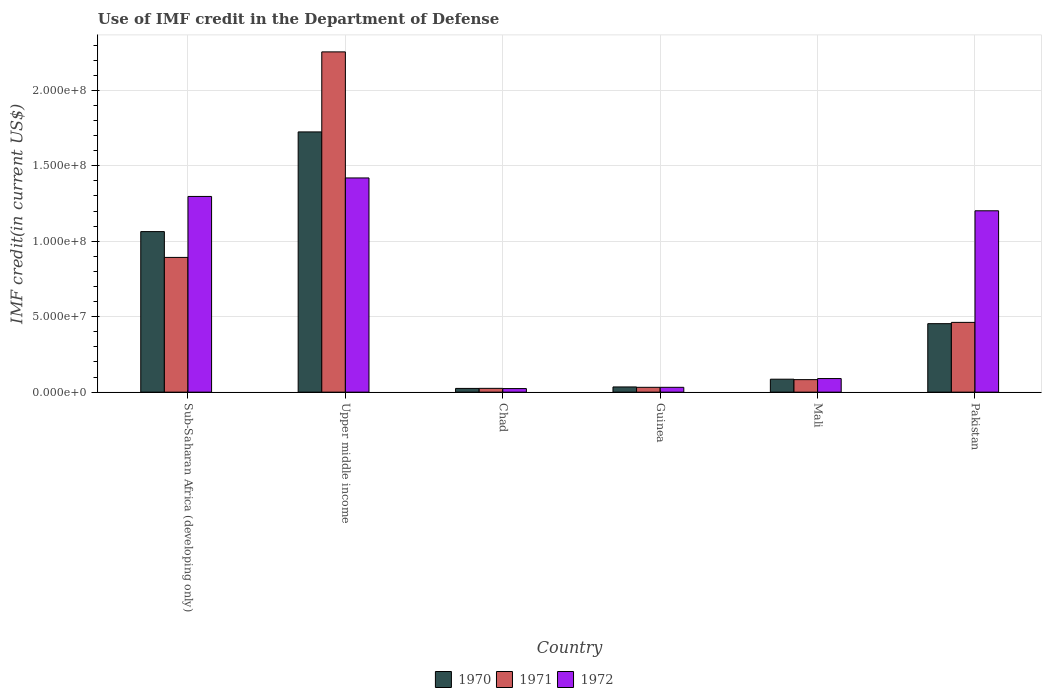How many groups of bars are there?
Offer a very short reply. 6. How many bars are there on the 5th tick from the right?
Your answer should be compact. 3. What is the label of the 2nd group of bars from the left?
Your answer should be compact. Upper middle income. In how many cases, is the number of bars for a given country not equal to the number of legend labels?
Provide a succinct answer. 0. What is the IMF credit in the Department of Defense in 1972 in Upper middle income?
Keep it short and to the point. 1.42e+08. Across all countries, what is the maximum IMF credit in the Department of Defense in 1970?
Provide a short and direct response. 1.72e+08. Across all countries, what is the minimum IMF credit in the Department of Defense in 1972?
Give a very brief answer. 2.37e+06. In which country was the IMF credit in the Department of Defense in 1972 maximum?
Offer a terse response. Upper middle income. In which country was the IMF credit in the Department of Defense in 1971 minimum?
Keep it short and to the point. Chad. What is the total IMF credit in the Department of Defense in 1971 in the graph?
Offer a very short reply. 3.75e+08. What is the difference between the IMF credit in the Department of Defense in 1971 in Chad and that in Sub-Saharan Africa (developing only)?
Offer a very short reply. -8.68e+07. What is the difference between the IMF credit in the Department of Defense in 1970 in Guinea and the IMF credit in the Department of Defense in 1972 in Chad?
Your answer should be very brief. 1.08e+06. What is the average IMF credit in the Department of Defense in 1971 per country?
Keep it short and to the point. 6.25e+07. What is the difference between the IMF credit in the Department of Defense of/in 1972 and IMF credit in the Department of Defense of/in 1970 in Chad?
Keep it short and to the point. -1.03e+05. In how many countries, is the IMF credit in the Department of Defense in 1970 greater than 220000000 US$?
Offer a very short reply. 0. What is the ratio of the IMF credit in the Department of Defense in 1971 in Guinea to that in Pakistan?
Provide a succinct answer. 0.07. What is the difference between the highest and the second highest IMF credit in the Department of Defense in 1972?
Provide a short and direct response. 2.18e+07. What is the difference between the highest and the lowest IMF credit in the Department of Defense in 1972?
Provide a short and direct response. 1.40e+08. In how many countries, is the IMF credit in the Department of Defense in 1972 greater than the average IMF credit in the Department of Defense in 1972 taken over all countries?
Your answer should be compact. 3. Is the sum of the IMF credit in the Department of Defense in 1972 in Pakistan and Sub-Saharan Africa (developing only) greater than the maximum IMF credit in the Department of Defense in 1970 across all countries?
Make the answer very short. Yes. What does the 1st bar from the left in Sub-Saharan Africa (developing only) represents?
Your answer should be compact. 1970. How many bars are there?
Provide a succinct answer. 18. Are all the bars in the graph horizontal?
Provide a short and direct response. No. How many countries are there in the graph?
Your answer should be very brief. 6. What is the title of the graph?
Make the answer very short. Use of IMF credit in the Department of Defense. Does "1992" appear as one of the legend labels in the graph?
Provide a succinct answer. No. What is the label or title of the X-axis?
Your answer should be compact. Country. What is the label or title of the Y-axis?
Your response must be concise. IMF credit(in current US$). What is the IMF credit(in current US$) in 1970 in Sub-Saharan Africa (developing only)?
Your response must be concise. 1.06e+08. What is the IMF credit(in current US$) in 1971 in Sub-Saharan Africa (developing only)?
Offer a terse response. 8.93e+07. What is the IMF credit(in current US$) in 1972 in Sub-Saharan Africa (developing only)?
Your answer should be compact. 1.30e+08. What is the IMF credit(in current US$) in 1970 in Upper middle income?
Your response must be concise. 1.72e+08. What is the IMF credit(in current US$) of 1971 in Upper middle income?
Make the answer very short. 2.25e+08. What is the IMF credit(in current US$) of 1972 in Upper middle income?
Provide a succinct answer. 1.42e+08. What is the IMF credit(in current US$) in 1970 in Chad?
Ensure brevity in your answer.  2.47e+06. What is the IMF credit(in current US$) of 1971 in Chad?
Provide a short and direct response. 2.52e+06. What is the IMF credit(in current US$) of 1972 in Chad?
Offer a terse response. 2.37e+06. What is the IMF credit(in current US$) of 1970 in Guinea?
Provide a short and direct response. 3.45e+06. What is the IMF credit(in current US$) of 1971 in Guinea?
Give a very brief answer. 3.20e+06. What is the IMF credit(in current US$) of 1972 in Guinea?
Offer a very short reply. 3.20e+06. What is the IMF credit(in current US$) in 1970 in Mali?
Keep it short and to the point. 8.58e+06. What is the IMF credit(in current US$) of 1971 in Mali?
Your response must be concise. 8.30e+06. What is the IMF credit(in current US$) in 1972 in Mali?
Your response must be concise. 9.01e+06. What is the IMF credit(in current US$) in 1970 in Pakistan?
Your answer should be compact. 4.54e+07. What is the IMF credit(in current US$) of 1971 in Pakistan?
Offer a very short reply. 4.62e+07. What is the IMF credit(in current US$) in 1972 in Pakistan?
Provide a succinct answer. 1.20e+08. Across all countries, what is the maximum IMF credit(in current US$) of 1970?
Your answer should be compact. 1.72e+08. Across all countries, what is the maximum IMF credit(in current US$) in 1971?
Make the answer very short. 2.25e+08. Across all countries, what is the maximum IMF credit(in current US$) of 1972?
Ensure brevity in your answer.  1.42e+08. Across all countries, what is the minimum IMF credit(in current US$) of 1970?
Your answer should be compact. 2.47e+06. Across all countries, what is the minimum IMF credit(in current US$) of 1971?
Your response must be concise. 2.52e+06. Across all countries, what is the minimum IMF credit(in current US$) in 1972?
Your answer should be compact. 2.37e+06. What is the total IMF credit(in current US$) in 1970 in the graph?
Your response must be concise. 3.39e+08. What is the total IMF credit(in current US$) of 1971 in the graph?
Provide a succinct answer. 3.75e+08. What is the total IMF credit(in current US$) in 1972 in the graph?
Provide a short and direct response. 4.06e+08. What is the difference between the IMF credit(in current US$) of 1970 in Sub-Saharan Africa (developing only) and that in Upper middle income?
Ensure brevity in your answer.  -6.61e+07. What is the difference between the IMF credit(in current US$) in 1971 in Sub-Saharan Africa (developing only) and that in Upper middle income?
Your answer should be very brief. -1.36e+08. What is the difference between the IMF credit(in current US$) of 1972 in Sub-Saharan Africa (developing only) and that in Upper middle income?
Ensure brevity in your answer.  -1.23e+07. What is the difference between the IMF credit(in current US$) of 1970 in Sub-Saharan Africa (developing only) and that in Chad?
Offer a terse response. 1.04e+08. What is the difference between the IMF credit(in current US$) in 1971 in Sub-Saharan Africa (developing only) and that in Chad?
Give a very brief answer. 8.68e+07. What is the difference between the IMF credit(in current US$) in 1972 in Sub-Saharan Africa (developing only) and that in Chad?
Your answer should be very brief. 1.27e+08. What is the difference between the IMF credit(in current US$) of 1970 in Sub-Saharan Africa (developing only) and that in Guinea?
Make the answer very short. 1.03e+08. What is the difference between the IMF credit(in current US$) of 1971 in Sub-Saharan Africa (developing only) and that in Guinea?
Offer a very short reply. 8.61e+07. What is the difference between the IMF credit(in current US$) in 1972 in Sub-Saharan Africa (developing only) and that in Guinea?
Provide a short and direct response. 1.26e+08. What is the difference between the IMF credit(in current US$) of 1970 in Sub-Saharan Africa (developing only) and that in Mali?
Make the answer very short. 9.78e+07. What is the difference between the IMF credit(in current US$) of 1971 in Sub-Saharan Africa (developing only) and that in Mali?
Your response must be concise. 8.10e+07. What is the difference between the IMF credit(in current US$) of 1972 in Sub-Saharan Africa (developing only) and that in Mali?
Offer a terse response. 1.21e+08. What is the difference between the IMF credit(in current US$) in 1970 in Sub-Saharan Africa (developing only) and that in Pakistan?
Make the answer very short. 6.10e+07. What is the difference between the IMF credit(in current US$) of 1971 in Sub-Saharan Africa (developing only) and that in Pakistan?
Ensure brevity in your answer.  4.31e+07. What is the difference between the IMF credit(in current US$) in 1972 in Sub-Saharan Africa (developing only) and that in Pakistan?
Your response must be concise. 9.50e+06. What is the difference between the IMF credit(in current US$) of 1970 in Upper middle income and that in Chad?
Keep it short and to the point. 1.70e+08. What is the difference between the IMF credit(in current US$) in 1971 in Upper middle income and that in Chad?
Keep it short and to the point. 2.23e+08. What is the difference between the IMF credit(in current US$) in 1972 in Upper middle income and that in Chad?
Give a very brief answer. 1.40e+08. What is the difference between the IMF credit(in current US$) in 1970 in Upper middle income and that in Guinea?
Your answer should be compact. 1.69e+08. What is the difference between the IMF credit(in current US$) in 1971 in Upper middle income and that in Guinea?
Offer a terse response. 2.22e+08. What is the difference between the IMF credit(in current US$) of 1972 in Upper middle income and that in Guinea?
Give a very brief answer. 1.39e+08. What is the difference between the IMF credit(in current US$) in 1970 in Upper middle income and that in Mali?
Your answer should be very brief. 1.64e+08. What is the difference between the IMF credit(in current US$) in 1971 in Upper middle income and that in Mali?
Provide a succinct answer. 2.17e+08. What is the difference between the IMF credit(in current US$) in 1972 in Upper middle income and that in Mali?
Offer a very short reply. 1.33e+08. What is the difference between the IMF credit(in current US$) of 1970 in Upper middle income and that in Pakistan?
Provide a succinct answer. 1.27e+08. What is the difference between the IMF credit(in current US$) of 1971 in Upper middle income and that in Pakistan?
Offer a very short reply. 1.79e+08. What is the difference between the IMF credit(in current US$) in 1972 in Upper middle income and that in Pakistan?
Ensure brevity in your answer.  2.18e+07. What is the difference between the IMF credit(in current US$) in 1970 in Chad and that in Guinea?
Offer a terse response. -9.80e+05. What is the difference between the IMF credit(in current US$) of 1971 in Chad and that in Guinea?
Ensure brevity in your answer.  -6.84e+05. What is the difference between the IMF credit(in current US$) of 1972 in Chad and that in Guinea?
Provide a short and direct response. -8.36e+05. What is the difference between the IMF credit(in current US$) of 1970 in Chad and that in Mali?
Your response must be concise. -6.11e+06. What is the difference between the IMF credit(in current US$) of 1971 in Chad and that in Mali?
Your answer should be compact. -5.78e+06. What is the difference between the IMF credit(in current US$) in 1972 in Chad and that in Mali?
Offer a terse response. -6.64e+06. What is the difference between the IMF credit(in current US$) in 1970 in Chad and that in Pakistan?
Keep it short and to the point. -4.29e+07. What is the difference between the IMF credit(in current US$) of 1971 in Chad and that in Pakistan?
Provide a short and direct response. -4.37e+07. What is the difference between the IMF credit(in current US$) of 1972 in Chad and that in Pakistan?
Give a very brief answer. -1.18e+08. What is the difference between the IMF credit(in current US$) in 1970 in Guinea and that in Mali?
Give a very brief answer. -5.13e+06. What is the difference between the IMF credit(in current US$) of 1971 in Guinea and that in Mali?
Ensure brevity in your answer.  -5.09e+06. What is the difference between the IMF credit(in current US$) in 1972 in Guinea and that in Mali?
Keep it short and to the point. -5.81e+06. What is the difference between the IMF credit(in current US$) of 1970 in Guinea and that in Pakistan?
Your answer should be compact. -4.19e+07. What is the difference between the IMF credit(in current US$) of 1971 in Guinea and that in Pakistan?
Offer a very short reply. -4.30e+07. What is the difference between the IMF credit(in current US$) in 1972 in Guinea and that in Pakistan?
Provide a short and direct response. -1.17e+08. What is the difference between the IMF credit(in current US$) of 1970 in Mali and that in Pakistan?
Offer a terse response. -3.68e+07. What is the difference between the IMF credit(in current US$) in 1971 in Mali and that in Pakistan?
Your response must be concise. -3.79e+07. What is the difference between the IMF credit(in current US$) of 1972 in Mali and that in Pakistan?
Your response must be concise. -1.11e+08. What is the difference between the IMF credit(in current US$) of 1970 in Sub-Saharan Africa (developing only) and the IMF credit(in current US$) of 1971 in Upper middle income?
Your answer should be compact. -1.19e+08. What is the difference between the IMF credit(in current US$) in 1970 in Sub-Saharan Africa (developing only) and the IMF credit(in current US$) in 1972 in Upper middle income?
Ensure brevity in your answer.  -3.56e+07. What is the difference between the IMF credit(in current US$) of 1971 in Sub-Saharan Africa (developing only) and the IMF credit(in current US$) of 1972 in Upper middle income?
Keep it short and to the point. -5.27e+07. What is the difference between the IMF credit(in current US$) in 1970 in Sub-Saharan Africa (developing only) and the IMF credit(in current US$) in 1971 in Chad?
Ensure brevity in your answer.  1.04e+08. What is the difference between the IMF credit(in current US$) of 1970 in Sub-Saharan Africa (developing only) and the IMF credit(in current US$) of 1972 in Chad?
Make the answer very short. 1.04e+08. What is the difference between the IMF credit(in current US$) of 1971 in Sub-Saharan Africa (developing only) and the IMF credit(in current US$) of 1972 in Chad?
Offer a terse response. 8.69e+07. What is the difference between the IMF credit(in current US$) of 1970 in Sub-Saharan Africa (developing only) and the IMF credit(in current US$) of 1971 in Guinea?
Your response must be concise. 1.03e+08. What is the difference between the IMF credit(in current US$) of 1970 in Sub-Saharan Africa (developing only) and the IMF credit(in current US$) of 1972 in Guinea?
Provide a short and direct response. 1.03e+08. What is the difference between the IMF credit(in current US$) in 1971 in Sub-Saharan Africa (developing only) and the IMF credit(in current US$) in 1972 in Guinea?
Provide a succinct answer. 8.61e+07. What is the difference between the IMF credit(in current US$) of 1970 in Sub-Saharan Africa (developing only) and the IMF credit(in current US$) of 1971 in Mali?
Make the answer very short. 9.81e+07. What is the difference between the IMF credit(in current US$) of 1970 in Sub-Saharan Africa (developing only) and the IMF credit(in current US$) of 1972 in Mali?
Offer a very short reply. 9.74e+07. What is the difference between the IMF credit(in current US$) in 1971 in Sub-Saharan Africa (developing only) and the IMF credit(in current US$) in 1972 in Mali?
Give a very brief answer. 8.03e+07. What is the difference between the IMF credit(in current US$) in 1970 in Sub-Saharan Africa (developing only) and the IMF credit(in current US$) in 1971 in Pakistan?
Give a very brief answer. 6.02e+07. What is the difference between the IMF credit(in current US$) of 1970 in Sub-Saharan Africa (developing only) and the IMF credit(in current US$) of 1972 in Pakistan?
Provide a short and direct response. -1.38e+07. What is the difference between the IMF credit(in current US$) of 1971 in Sub-Saharan Africa (developing only) and the IMF credit(in current US$) of 1972 in Pakistan?
Your answer should be compact. -3.09e+07. What is the difference between the IMF credit(in current US$) of 1970 in Upper middle income and the IMF credit(in current US$) of 1971 in Chad?
Provide a succinct answer. 1.70e+08. What is the difference between the IMF credit(in current US$) of 1970 in Upper middle income and the IMF credit(in current US$) of 1972 in Chad?
Provide a short and direct response. 1.70e+08. What is the difference between the IMF credit(in current US$) in 1971 in Upper middle income and the IMF credit(in current US$) in 1972 in Chad?
Make the answer very short. 2.23e+08. What is the difference between the IMF credit(in current US$) in 1970 in Upper middle income and the IMF credit(in current US$) in 1971 in Guinea?
Your answer should be compact. 1.69e+08. What is the difference between the IMF credit(in current US$) in 1970 in Upper middle income and the IMF credit(in current US$) in 1972 in Guinea?
Offer a very short reply. 1.69e+08. What is the difference between the IMF credit(in current US$) of 1971 in Upper middle income and the IMF credit(in current US$) of 1972 in Guinea?
Provide a succinct answer. 2.22e+08. What is the difference between the IMF credit(in current US$) in 1970 in Upper middle income and the IMF credit(in current US$) in 1971 in Mali?
Your answer should be compact. 1.64e+08. What is the difference between the IMF credit(in current US$) of 1970 in Upper middle income and the IMF credit(in current US$) of 1972 in Mali?
Your answer should be very brief. 1.63e+08. What is the difference between the IMF credit(in current US$) of 1971 in Upper middle income and the IMF credit(in current US$) of 1972 in Mali?
Provide a short and direct response. 2.16e+08. What is the difference between the IMF credit(in current US$) in 1970 in Upper middle income and the IMF credit(in current US$) in 1971 in Pakistan?
Make the answer very short. 1.26e+08. What is the difference between the IMF credit(in current US$) in 1970 in Upper middle income and the IMF credit(in current US$) in 1972 in Pakistan?
Give a very brief answer. 5.23e+07. What is the difference between the IMF credit(in current US$) of 1971 in Upper middle income and the IMF credit(in current US$) of 1972 in Pakistan?
Offer a terse response. 1.05e+08. What is the difference between the IMF credit(in current US$) of 1970 in Chad and the IMF credit(in current US$) of 1971 in Guinea?
Your answer should be very brief. -7.33e+05. What is the difference between the IMF credit(in current US$) of 1970 in Chad and the IMF credit(in current US$) of 1972 in Guinea?
Provide a short and direct response. -7.33e+05. What is the difference between the IMF credit(in current US$) of 1971 in Chad and the IMF credit(in current US$) of 1972 in Guinea?
Keep it short and to the point. -6.84e+05. What is the difference between the IMF credit(in current US$) in 1970 in Chad and the IMF credit(in current US$) in 1971 in Mali?
Ensure brevity in your answer.  -5.82e+06. What is the difference between the IMF credit(in current US$) in 1970 in Chad and the IMF credit(in current US$) in 1972 in Mali?
Offer a very short reply. -6.54e+06. What is the difference between the IMF credit(in current US$) in 1971 in Chad and the IMF credit(in current US$) in 1972 in Mali?
Offer a very short reply. -6.49e+06. What is the difference between the IMF credit(in current US$) in 1970 in Chad and the IMF credit(in current US$) in 1971 in Pakistan?
Your answer should be very brief. -4.38e+07. What is the difference between the IMF credit(in current US$) of 1970 in Chad and the IMF credit(in current US$) of 1972 in Pakistan?
Offer a terse response. -1.18e+08. What is the difference between the IMF credit(in current US$) of 1971 in Chad and the IMF credit(in current US$) of 1972 in Pakistan?
Offer a very short reply. -1.18e+08. What is the difference between the IMF credit(in current US$) of 1970 in Guinea and the IMF credit(in current US$) of 1971 in Mali?
Your response must be concise. -4.84e+06. What is the difference between the IMF credit(in current US$) of 1970 in Guinea and the IMF credit(in current US$) of 1972 in Mali?
Provide a short and direct response. -5.56e+06. What is the difference between the IMF credit(in current US$) in 1971 in Guinea and the IMF credit(in current US$) in 1972 in Mali?
Provide a short and direct response. -5.81e+06. What is the difference between the IMF credit(in current US$) of 1970 in Guinea and the IMF credit(in current US$) of 1971 in Pakistan?
Your answer should be very brief. -4.28e+07. What is the difference between the IMF credit(in current US$) in 1970 in Guinea and the IMF credit(in current US$) in 1972 in Pakistan?
Your answer should be very brief. -1.17e+08. What is the difference between the IMF credit(in current US$) in 1971 in Guinea and the IMF credit(in current US$) in 1972 in Pakistan?
Your response must be concise. -1.17e+08. What is the difference between the IMF credit(in current US$) of 1970 in Mali and the IMF credit(in current US$) of 1971 in Pakistan?
Keep it short and to the point. -3.77e+07. What is the difference between the IMF credit(in current US$) of 1970 in Mali and the IMF credit(in current US$) of 1972 in Pakistan?
Offer a terse response. -1.12e+08. What is the difference between the IMF credit(in current US$) of 1971 in Mali and the IMF credit(in current US$) of 1972 in Pakistan?
Offer a terse response. -1.12e+08. What is the average IMF credit(in current US$) in 1970 per country?
Keep it short and to the point. 5.65e+07. What is the average IMF credit(in current US$) in 1971 per country?
Your answer should be compact. 6.25e+07. What is the average IMF credit(in current US$) of 1972 per country?
Your response must be concise. 6.77e+07. What is the difference between the IMF credit(in current US$) in 1970 and IMF credit(in current US$) in 1971 in Sub-Saharan Africa (developing only)?
Your answer should be very brief. 1.71e+07. What is the difference between the IMF credit(in current US$) of 1970 and IMF credit(in current US$) of 1972 in Sub-Saharan Africa (developing only)?
Offer a very short reply. -2.33e+07. What is the difference between the IMF credit(in current US$) in 1971 and IMF credit(in current US$) in 1972 in Sub-Saharan Africa (developing only)?
Your answer should be compact. -4.04e+07. What is the difference between the IMF credit(in current US$) in 1970 and IMF credit(in current US$) in 1971 in Upper middle income?
Ensure brevity in your answer.  -5.30e+07. What is the difference between the IMF credit(in current US$) in 1970 and IMF credit(in current US$) in 1972 in Upper middle income?
Provide a short and direct response. 3.05e+07. What is the difference between the IMF credit(in current US$) of 1971 and IMF credit(in current US$) of 1972 in Upper middle income?
Your answer should be very brief. 8.35e+07. What is the difference between the IMF credit(in current US$) of 1970 and IMF credit(in current US$) of 1971 in Chad?
Give a very brief answer. -4.90e+04. What is the difference between the IMF credit(in current US$) of 1970 and IMF credit(in current US$) of 1972 in Chad?
Ensure brevity in your answer.  1.03e+05. What is the difference between the IMF credit(in current US$) of 1971 and IMF credit(in current US$) of 1972 in Chad?
Your answer should be very brief. 1.52e+05. What is the difference between the IMF credit(in current US$) in 1970 and IMF credit(in current US$) in 1971 in Guinea?
Provide a succinct answer. 2.47e+05. What is the difference between the IMF credit(in current US$) in 1970 and IMF credit(in current US$) in 1972 in Guinea?
Your response must be concise. 2.47e+05. What is the difference between the IMF credit(in current US$) in 1970 and IMF credit(in current US$) in 1971 in Mali?
Your response must be concise. 2.85e+05. What is the difference between the IMF credit(in current US$) of 1970 and IMF credit(in current US$) of 1972 in Mali?
Ensure brevity in your answer.  -4.31e+05. What is the difference between the IMF credit(in current US$) of 1971 and IMF credit(in current US$) of 1972 in Mali?
Make the answer very short. -7.16e+05. What is the difference between the IMF credit(in current US$) of 1970 and IMF credit(in current US$) of 1971 in Pakistan?
Give a very brief answer. -8.56e+05. What is the difference between the IMF credit(in current US$) in 1970 and IMF credit(in current US$) in 1972 in Pakistan?
Give a very brief answer. -7.48e+07. What is the difference between the IMF credit(in current US$) in 1971 and IMF credit(in current US$) in 1972 in Pakistan?
Provide a short and direct response. -7.40e+07. What is the ratio of the IMF credit(in current US$) in 1970 in Sub-Saharan Africa (developing only) to that in Upper middle income?
Provide a short and direct response. 0.62. What is the ratio of the IMF credit(in current US$) of 1971 in Sub-Saharan Africa (developing only) to that in Upper middle income?
Offer a very short reply. 0.4. What is the ratio of the IMF credit(in current US$) of 1972 in Sub-Saharan Africa (developing only) to that in Upper middle income?
Keep it short and to the point. 0.91. What is the ratio of the IMF credit(in current US$) in 1970 in Sub-Saharan Africa (developing only) to that in Chad?
Your answer should be compact. 43.07. What is the ratio of the IMF credit(in current US$) of 1971 in Sub-Saharan Africa (developing only) to that in Chad?
Offer a very short reply. 35.45. What is the ratio of the IMF credit(in current US$) in 1972 in Sub-Saharan Africa (developing only) to that in Chad?
Offer a very short reply. 54.79. What is the ratio of the IMF credit(in current US$) of 1970 in Sub-Saharan Africa (developing only) to that in Guinea?
Keep it short and to the point. 30.84. What is the ratio of the IMF credit(in current US$) in 1971 in Sub-Saharan Africa (developing only) to that in Guinea?
Give a very brief answer. 27.88. What is the ratio of the IMF credit(in current US$) of 1972 in Sub-Saharan Africa (developing only) to that in Guinea?
Provide a succinct answer. 40.49. What is the ratio of the IMF credit(in current US$) of 1970 in Sub-Saharan Africa (developing only) to that in Mali?
Your answer should be very brief. 12.4. What is the ratio of the IMF credit(in current US$) in 1971 in Sub-Saharan Africa (developing only) to that in Mali?
Offer a terse response. 10.76. What is the ratio of the IMF credit(in current US$) in 1972 in Sub-Saharan Africa (developing only) to that in Mali?
Offer a terse response. 14.39. What is the ratio of the IMF credit(in current US$) of 1970 in Sub-Saharan Africa (developing only) to that in Pakistan?
Provide a short and direct response. 2.34. What is the ratio of the IMF credit(in current US$) of 1971 in Sub-Saharan Africa (developing only) to that in Pakistan?
Provide a succinct answer. 1.93. What is the ratio of the IMF credit(in current US$) in 1972 in Sub-Saharan Africa (developing only) to that in Pakistan?
Your response must be concise. 1.08. What is the ratio of the IMF credit(in current US$) of 1970 in Upper middle income to that in Chad?
Your answer should be very brief. 69.82. What is the ratio of the IMF credit(in current US$) of 1971 in Upper middle income to that in Chad?
Give a very brief answer. 89.51. What is the ratio of the IMF credit(in current US$) in 1972 in Upper middle income to that in Chad?
Your answer should be compact. 59.97. What is the ratio of the IMF credit(in current US$) of 1970 in Upper middle income to that in Guinea?
Make the answer very short. 49.99. What is the ratio of the IMF credit(in current US$) of 1971 in Upper middle income to that in Guinea?
Ensure brevity in your answer.  70.4. What is the ratio of the IMF credit(in current US$) in 1972 in Upper middle income to that in Guinea?
Provide a short and direct response. 44.32. What is the ratio of the IMF credit(in current US$) in 1970 in Upper middle income to that in Mali?
Your answer should be very brief. 20.1. What is the ratio of the IMF credit(in current US$) in 1971 in Upper middle income to that in Mali?
Ensure brevity in your answer.  27.18. What is the ratio of the IMF credit(in current US$) of 1972 in Upper middle income to that in Mali?
Provide a succinct answer. 15.75. What is the ratio of the IMF credit(in current US$) in 1970 in Upper middle income to that in Pakistan?
Offer a terse response. 3.8. What is the ratio of the IMF credit(in current US$) in 1971 in Upper middle income to that in Pakistan?
Make the answer very short. 4.88. What is the ratio of the IMF credit(in current US$) in 1972 in Upper middle income to that in Pakistan?
Provide a succinct answer. 1.18. What is the ratio of the IMF credit(in current US$) of 1970 in Chad to that in Guinea?
Offer a terse response. 0.72. What is the ratio of the IMF credit(in current US$) in 1971 in Chad to that in Guinea?
Offer a terse response. 0.79. What is the ratio of the IMF credit(in current US$) of 1972 in Chad to that in Guinea?
Provide a succinct answer. 0.74. What is the ratio of the IMF credit(in current US$) in 1970 in Chad to that in Mali?
Offer a very short reply. 0.29. What is the ratio of the IMF credit(in current US$) of 1971 in Chad to that in Mali?
Your answer should be compact. 0.3. What is the ratio of the IMF credit(in current US$) in 1972 in Chad to that in Mali?
Your response must be concise. 0.26. What is the ratio of the IMF credit(in current US$) in 1970 in Chad to that in Pakistan?
Your answer should be very brief. 0.05. What is the ratio of the IMF credit(in current US$) in 1971 in Chad to that in Pakistan?
Ensure brevity in your answer.  0.05. What is the ratio of the IMF credit(in current US$) in 1972 in Chad to that in Pakistan?
Your answer should be compact. 0.02. What is the ratio of the IMF credit(in current US$) in 1970 in Guinea to that in Mali?
Provide a short and direct response. 0.4. What is the ratio of the IMF credit(in current US$) of 1971 in Guinea to that in Mali?
Offer a terse response. 0.39. What is the ratio of the IMF credit(in current US$) of 1972 in Guinea to that in Mali?
Your answer should be compact. 0.36. What is the ratio of the IMF credit(in current US$) in 1970 in Guinea to that in Pakistan?
Provide a succinct answer. 0.08. What is the ratio of the IMF credit(in current US$) of 1971 in Guinea to that in Pakistan?
Provide a short and direct response. 0.07. What is the ratio of the IMF credit(in current US$) of 1972 in Guinea to that in Pakistan?
Provide a short and direct response. 0.03. What is the ratio of the IMF credit(in current US$) of 1970 in Mali to that in Pakistan?
Give a very brief answer. 0.19. What is the ratio of the IMF credit(in current US$) in 1971 in Mali to that in Pakistan?
Provide a succinct answer. 0.18. What is the ratio of the IMF credit(in current US$) in 1972 in Mali to that in Pakistan?
Your answer should be compact. 0.07. What is the difference between the highest and the second highest IMF credit(in current US$) of 1970?
Make the answer very short. 6.61e+07. What is the difference between the highest and the second highest IMF credit(in current US$) in 1971?
Offer a terse response. 1.36e+08. What is the difference between the highest and the second highest IMF credit(in current US$) of 1972?
Your answer should be compact. 1.23e+07. What is the difference between the highest and the lowest IMF credit(in current US$) in 1970?
Offer a very short reply. 1.70e+08. What is the difference between the highest and the lowest IMF credit(in current US$) of 1971?
Keep it short and to the point. 2.23e+08. What is the difference between the highest and the lowest IMF credit(in current US$) of 1972?
Offer a very short reply. 1.40e+08. 